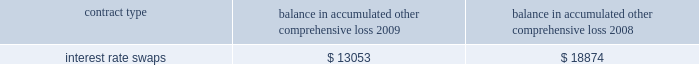The table below represents unrealized losses related to derivative amounts included in 201caccumulated other comprehensive loss 201d for the years ended december 31 , ( in thousands ) : balance in accumulated other comprehensive loss .
Note 9 2013 fair value measurements the company uses the fair value hierarchy , which prioritizes the inputs used to measure the fair value of certain of its financial instruments .
The hierarchy gives the highest priority to unadjusted quoted prices in active markets for identical assets or liabilities ( level 1 measurement ) and the lowest priority to unobservable inputs ( level 3 measurement ) .
The three levels of the fair value hierarchy are set forth below : 2022 level 1 2013 quoted prices are available in active markets for identical assets or liabilities as of the reporting date .
Active markets are those in which transactions for the asset or liability occur in sufficient frequency and volume to provide pricing information on an ongoing basis .
2022 level 2 2013 pricing inputs are other than quoted prices in active markets included in level 1 , which are either directly or indirectly observable as of the reporting date .
Level 2 includes those financial instruments that are valued using models or other valuation methodologies .
These models are primarily industry-standard models that consider various assumptions , including time value , volatility factors , and current market and contractual prices for the underlying instruments , as well as other relevant economic measures .
Substantially all of these assumptions are observable in the marketplace throughout the full term of the instrument , can be derived from observable data or are supported by observable levels at which transactions are executed in the marketplace .
2022 level 3 2013 pricing inputs include significant inputs that are generally less observable from objective sources .
These inputs may be used with internally developed methodologies that result in management 2019s best estimate of fair value from the perspective of a market participant .
The fair value of the interest rate swap transactions are based on the discounted net present value of the swap using third party quotes ( level 2 ) .
Changes in fair market value are recorded in other comprehensive income ( loss ) , and changes resulting from ineffectiveness are recorded in current earnings .
Assets and liabilities measured at fair value are based on one or more of three valuation techniques .
The three valuation techniques are identified in the table below and are as follows : a ) market approach 2013 prices and other relevant information generated by market transactions involving identical or comparable assets or liabilities b ) cost approach 2013 amount that would be required to replace the service capacity of an asset ( replacement cost ) c ) income approach 2013 techniques to convert future amounts to a single present amount based on market expectations ( including present value techniques , option-pricing and excess earnings models ) .
For unrealized losses related to derivative amounts included in 201caccumulated other comprehensive loss 201d for the years ended december 31 , ( in thousands ) , what was the average balance in accumulated other comprehensive loss for the two years? 
Computations: table_average(interest rate swaps, none)
Answer: 15963.5. 